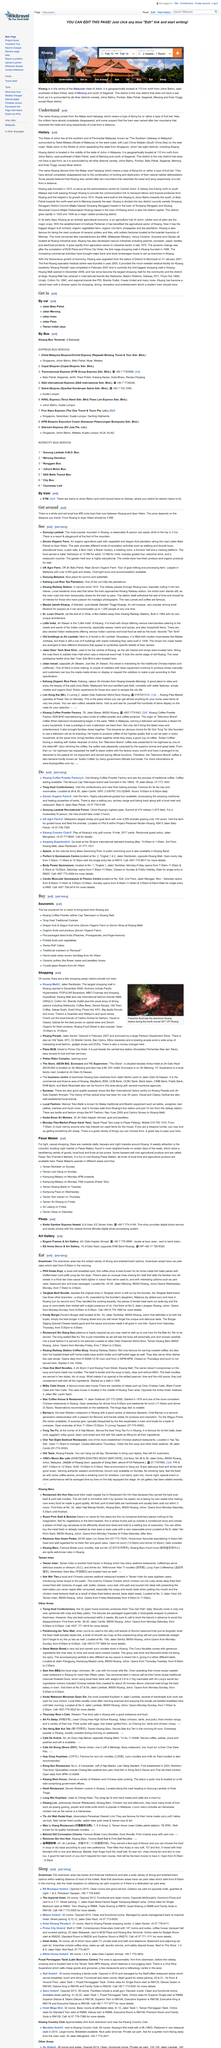Outline some significant characteristics in this image. The two titles in the article are 'Understand' and 'History', which provide a comprehensive overview of the topic at hand. The Malay word "keluang" refers to a type of fruit bat. Johor has a total of eight districts, including the district of Kluang. 